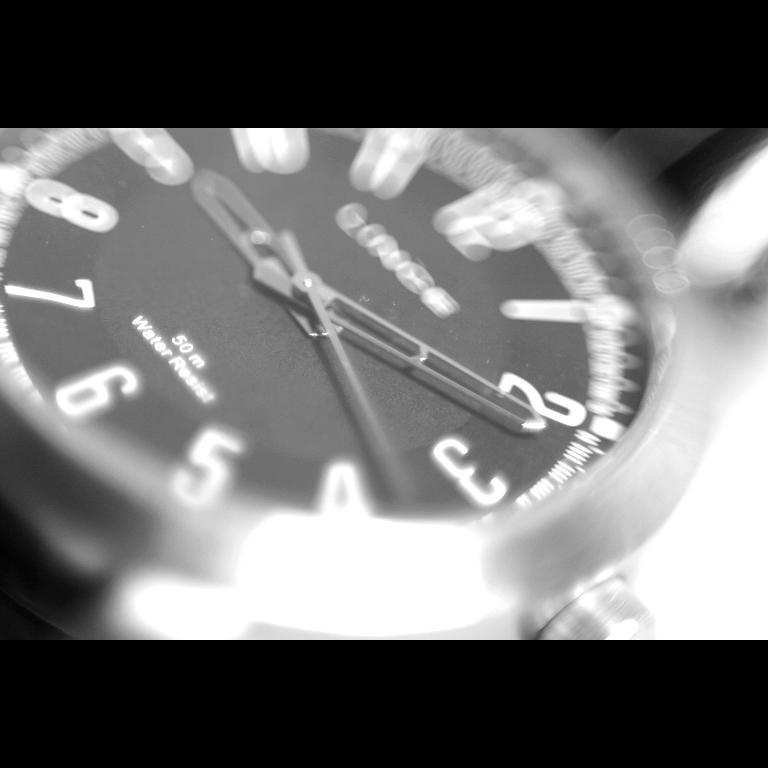<image>
Create a compact narrative representing the image presented. A watch that will resist water to 50km. 